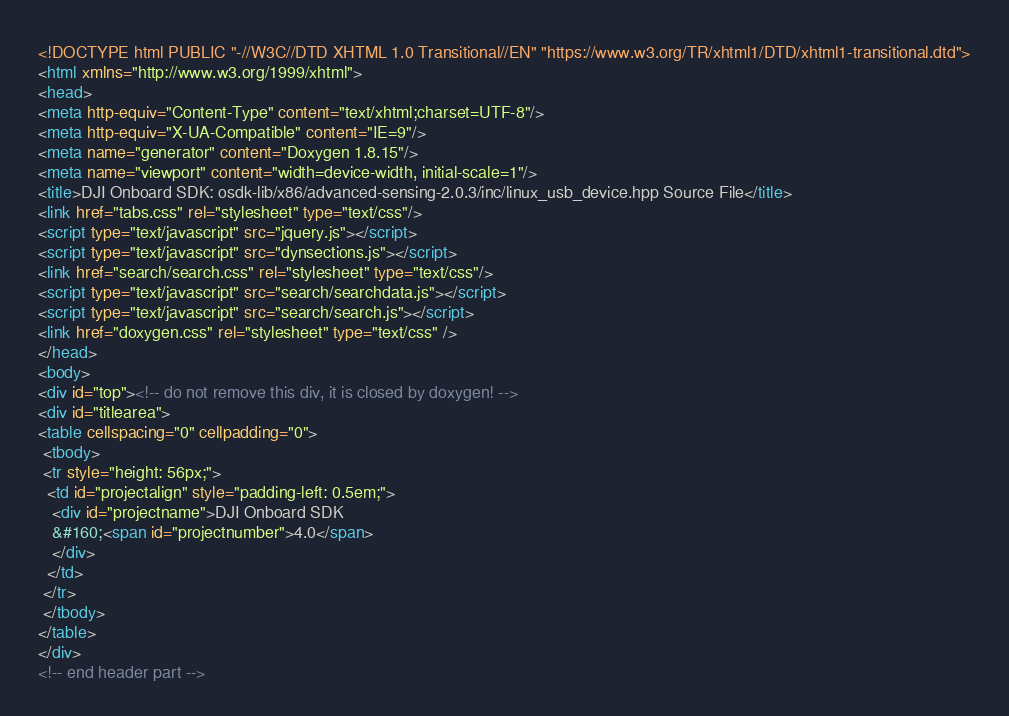<code> <loc_0><loc_0><loc_500><loc_500><_HTML_><!DOCTYPE html PUBLIC "-//W3C//DTD XHTML 1.0 Transitional//EN" "https://www.w3.org/TR/xhtml1/DTD/xhtml1-transitional.dtd">
<html xmlns="http://www.w3.org/1999/xhtml">
<head>
<meta http-equiv="Content-Type" content="text/xhtml;charset=UTF-8"/>
<meta http-equiv="X-UA-Compatible" content="IE=9"/>
<meta name="generator" content="Doxygen 1.8.15"/>
<meta name="viewport" content="width=device-width, initial-scale=1"/>
<title>DJI Onboard SDK: osdk-lib/x86/advanced-sensing-2.0.3/inc/linux_usb_device.hpp Source File</title>
<link href="tabs.css" rel="stylesheet" type="text/css"/>
<script type="text/javascript" src="jquery.js"></script>
<script type="text/javascript" src="dynsections.js"></script>
<link href="search/search.css" rel="stylesheet" type="text/css"/>
<script type="text/javascript" src="search/searchdata.js"></script>
<script type="text/javascript" src="search/search.js"></script>
<link href="doxygen.css" rel="stylesheet" type="text/css" />
</head>
<body>
<div id="top"><!-- do not remove this div, it is closed by doxygen! -->
<div id="titlearea">
<table cellspacing="0" cellpadding="0">
 <tbody>
 <tr style="height: 56px;">
  <td id="projectalign" style="padding-left: 0.5em;">
   <div id="projectname">DJI Onboard SDK
   &#160;<span id="projectnumber">4.0</span>
   </div>
  </td>
 </tr>
 </tbody>
</table>
</div>
<!-- end header part --></code> 